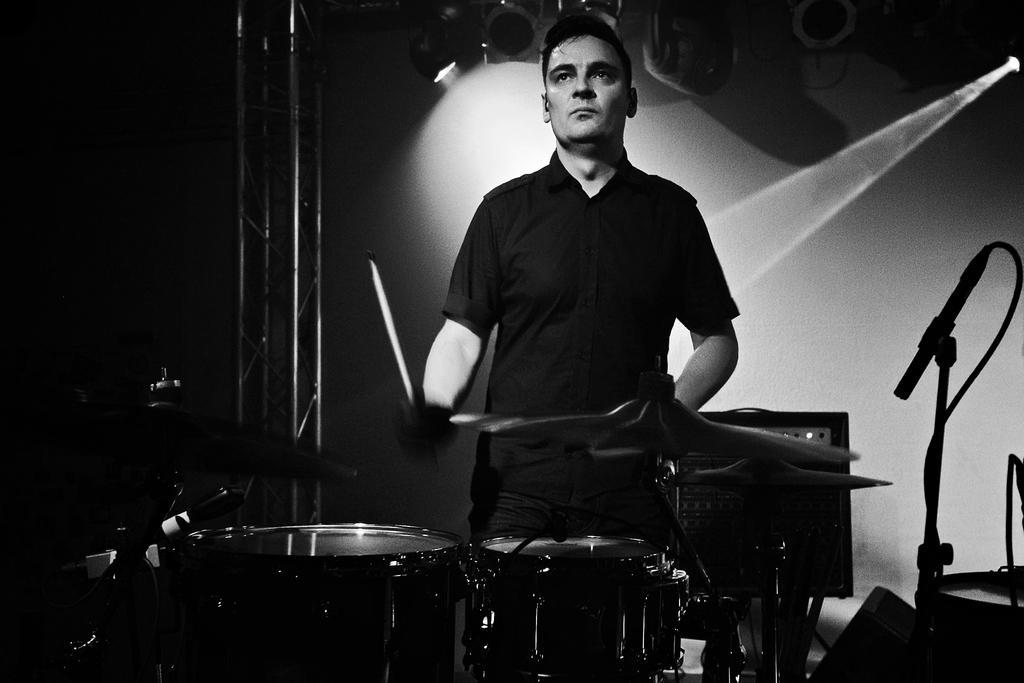Please provide a concise description of this image. This picture shows a man standing and playing drums on the dais we see a microphone on the right 